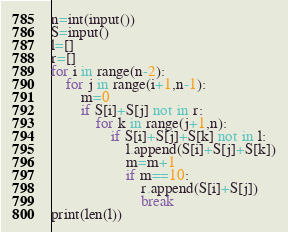<code> <loc_0><loc_0><loc_500><loc_500><_Python_>n=int(input())
S=input()
l=[]
r=[]
for i in range(n-2):
    for j in range(i+1,n-1):
        m=0
        if S[i]+S[j] not in r:
            for k in range(j+1,n):
                if S[i]+S[j]+S[k] not in l:
                    l.append(S[i]+S[j]+S[k])
                    m=m+1
                    if m==10:
                        r.append(S[i]+S[j])
                        break
print(len(l))</code> 